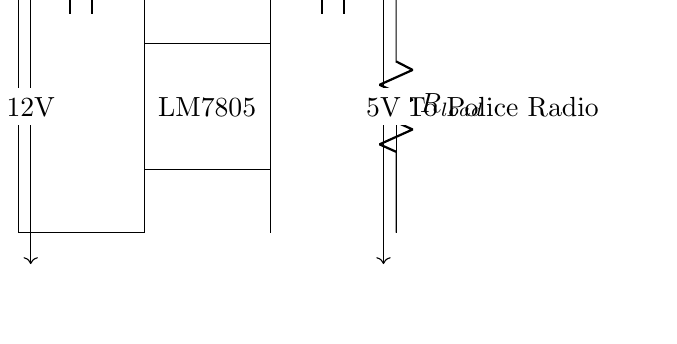What type of voltage regulator is shown in the circuit? The circuit diagram indicates the use of an LM7805 voltage regulator, which is a common type used for providing a stable 5V output. This is labeled in the rectangle section "LM7805".
Answer: LM7805 What is the input voltage for this circuit? The input voltage is specified as 12V, indicated by the labeling near the battery symbol on the left side of the circuit. This shows the voltage supplied to the circuit.
Answer: 12V What is the output voltage of the voltage regulator? The output voltage is indicated as 5V, which is provided by the LM7805 voltage regulator shown in the diagram. This is labeled near the output connection.
Answer: 5V What is the value of the input capacitor in the circuit? The input capacitor is noted as 100 microfarads, which is shown in the circuit next to the capacitor symbol connected to the input voltage.
Answer: 100 microfarads What is the purpose of the output resistor labeled R load? The purpose of the output resistor, labeled R load, is to represent the load connected to the output of the voltage regulator, simulating the behavior of the police radio receiving the 5V power.
Answer: To simulate the load of the police radio How does the voltage regulator ensure clear communication for the police radio? The voltage regulator maintains a constant output voltage of 5V regardless of fluctuations in the input voltage or load changes, which is essential for the reliable operation of sensitive communication equipment like a police radio.
Answer: By providing a stable 5V output What would happen if the input voltage was below 5V? If the input voltage were to drop below 5V, the LM7805 would not be able to regulate the output properly, resulting in insufficient voltage for the police radio, which could cause communication failures.
Answer: Insufficient voltage for operation 